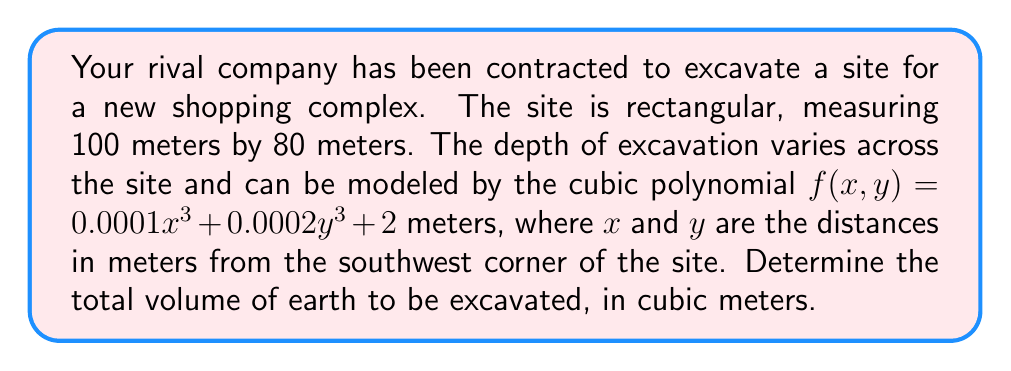Provide a solution to this math problem. To solve this problem, we need to calculate a double integral of the depth function over the rectangular area. Let's approach this step-by-step:

1) The volume is given by the integral:
   $$V = \int_0^{80} \int_0^{100} f(x,y) \, dx \, dy$$

2) Substituting the function:
   $$V = \int_0^{80} \int_0^{100} (0.0001x^3 + 0.0002y^3 + 2) \, dx \, dy$$

3) Let's integrate with respect to x first:
   $$V = \int_0^{80} \left[ 0.000025x^4 + 0.0002y^3x + 2x \right]_0^{100} \, dy$$

4) Evaluating the inner integral:
   $$V = \int_0^{80} (25 + 2y^3 + 200) \, dy$$

5) Simplifying:
   $$V = \int_0^{80} (2y^3 + 225) \, dy$$

6) Now integrate with respect to y:
   $$V = \left[ 0.5y^4 + 225y \right]_0^{80}$$

7) Evaluating the outer integral:
   $$V = (0.5 * 80^4 + 225 * 80) - (0.5 * 0^4 + 225 * 0)$$

8) Simplifying:
   $$V = 20,480,000 + 18,000 = 20,498,000$$

Therefore, the total volume of earth to be excavated is 20,498,000 cubic meters.
Answer: 20,498,000 cubic meters 